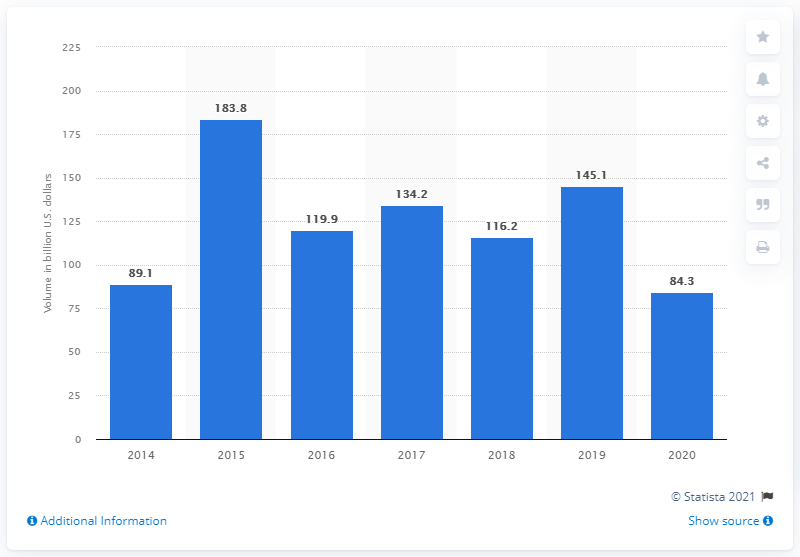Specify some key components in this picture. In 2020, the amount of merger and acquisition (M&A) transactions in the logistics and transportation industry was $84.3 billion. 